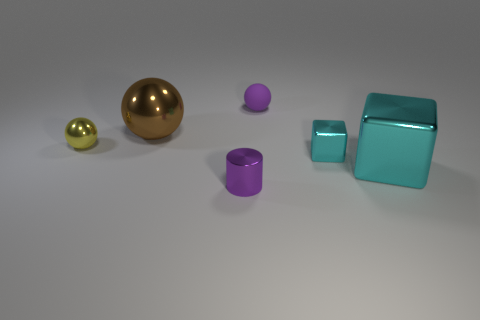There is a shiny block that is the same size as the yellow metallic ball; what color is it?
Your answer should be very brief. Cyan. Does the tiny sphere in front of the tiny matte sphere have the same material as the big brown object?
Make the answer very short. Yes. There is a big object that is on the left side of the purple thing right of the tiny shiny cylinder; is there a small purple object that is in front of it?
Provide a short and direct response. Yes. Is the shape of the tiny purple object that is behind the big cyan thing the same as  the yellow metallic thing?
Your answer should be very brief. Yes. The purple thing behind the tiny sphere that is to the left of the tiny cylinder is what shape?
Your response must be concise. Sphere. What is the size of the brown metal object behind the sphere that is left of the large shiny thing behind the tiny cyan shiny thing?
Provide a succinct answer. Large. There is a tiny metallic thing that is the same shape as the small matte object; what is its color?
Your answer should be very brief. Yellow. Does the yellow thing have the same size as the purple rubber ball?
Your response must be concise. Yes. There is a large thing on the left side of the purple shiny cylinder; what is it made of?
Offer a terse response. Metal. How many other objects are there of the same shape as the purple shiny thing?
Give a very brief answer. 0. 